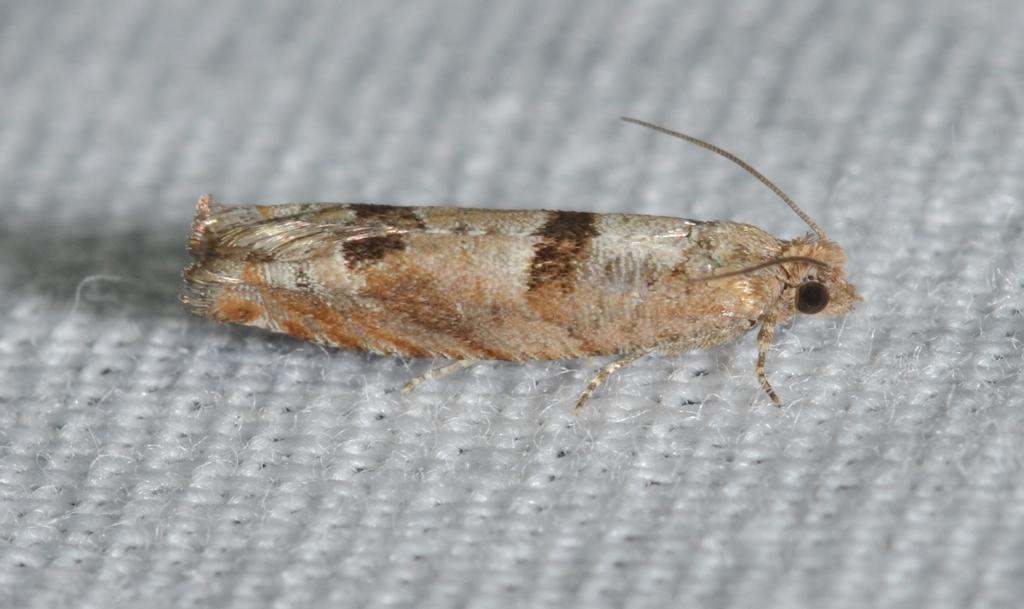What type of creature can be seen in the image? There is an insect in the image. Can you identify the specific type of insect? The insect is a brown house moth. What is the insect resting on in the image? The insect is on a cloth. What color is the cloth that the insect is on? The cloth is white in color. What is the insect's profit margin in the image? There is no information about profit margins in the image, as it features an insect on a cloth. 